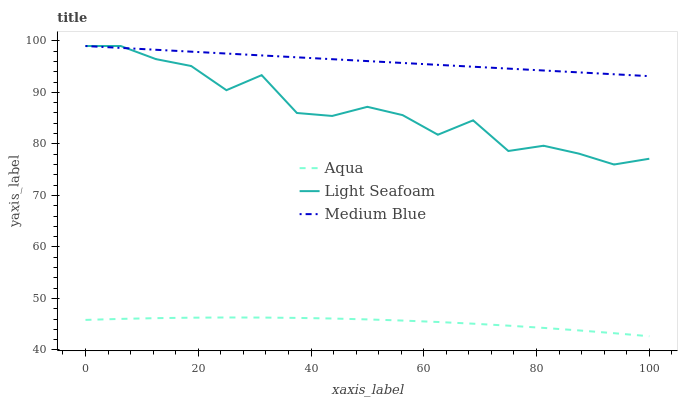Does Aqua have the minimum area under the curve?
Answer yes or no. Yes. Does Medium Blue have the maximum area under the curve?
Answer yes or no. Yes. Does Light Seafoam have the minimum area under the curve?
Answer yes or no. No. Does Light Seafoam have the maximum area under the curve?
Answer yes or no. No. Is Medium Blue the smoothest?
Answer yes or no. Yes. Is Light Seafoam the roughest?
Answer yes or no. Yes. Is Aqua the smoothest?
Answer yes or no. No. Is Aqua the roughest?
Answer yes or no. No. Does Aqua have the lowest value?
Answer yes or no. Yes. Does Light Seafoam have the lowest value?
Answer yes or no. No. Does Light Seafoam have the highest value?
Answer yes or no. Yes. Does Aqua have the highest value?
Answer yes or no. No. Is Aqua less than Light Seafoam?
Answer yes or no. Yes. Is Medium Blue greater than Aqua?
Answer yes or no. Yes. Does Light Seafoam intersect Medium Blue?
Answer yes or no. Yes. Is Light Seafoam less than Medium Blue?
Answer yes or no. No. Is Light Seafoam greater than Medium Blue?
Answer yes or no. No. Does Aqua intersect Light Seafoam?
Answer yes or no. No. 